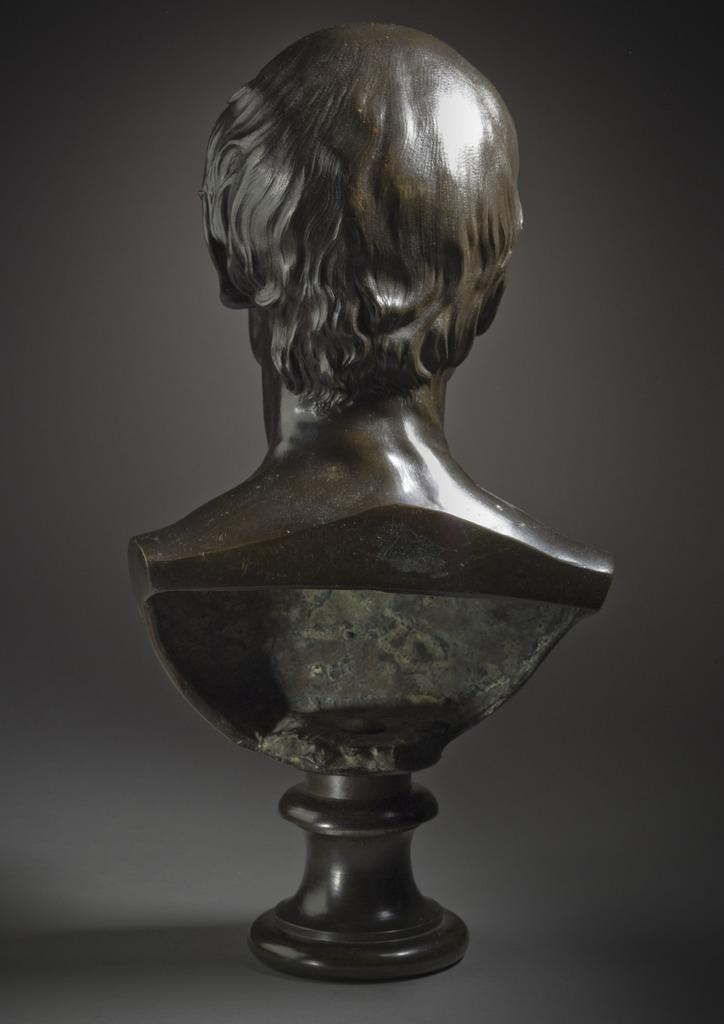What is the main subject of the image? There is a sculpture in the image. Can you describe the background of the image? The background of the image is blurry. What type of learning is taking place in the image? There is no learning taking place in the image, as it features a sculpture and a blurry background. Can you tell me which minister is present in the image? There is no minister present in the image; it only features a sculpture and a blurry background. 